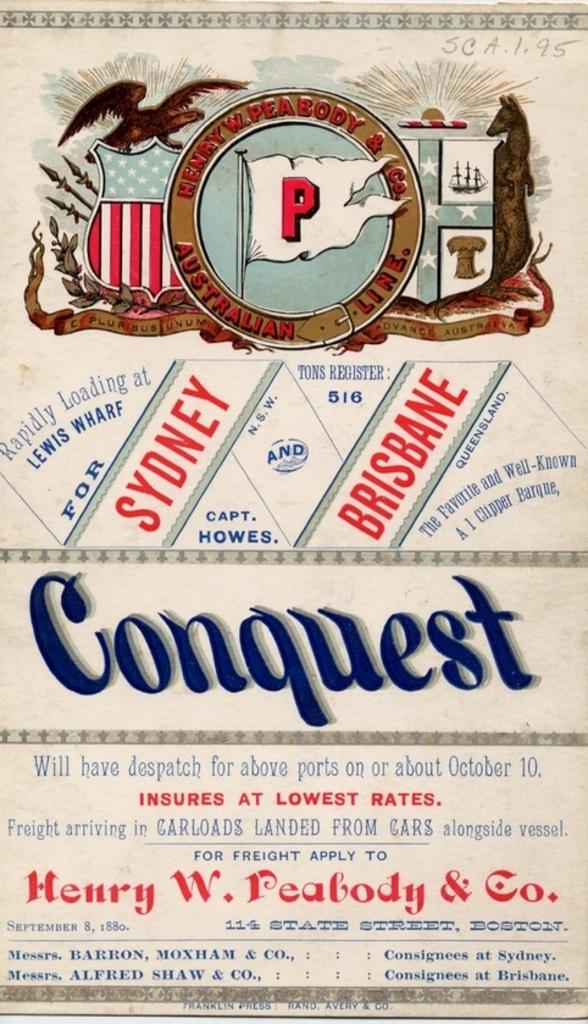<image>
Describe the image concisely. An advertisement for Henry W. Peabody & Co. in predominantly red, white and blue. 